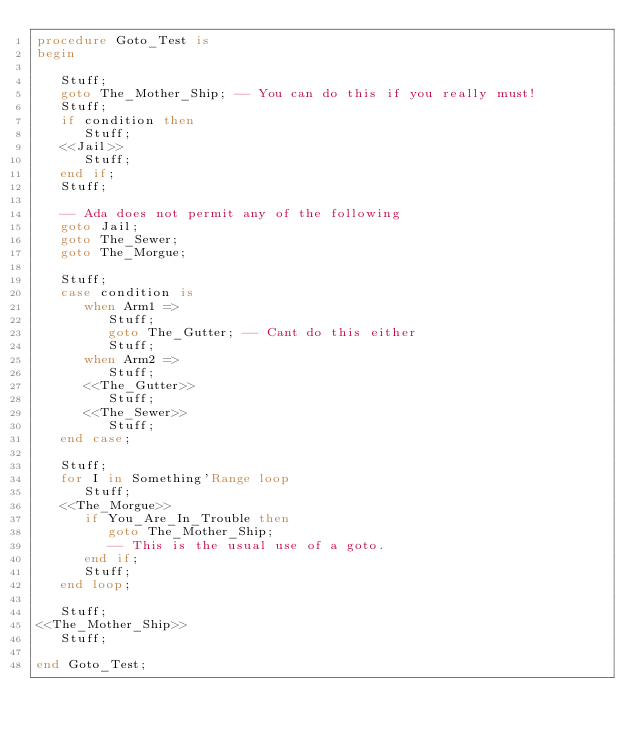<code> <loc_0><loc_0><loc_500><loc_500><_Ada_>procedure Goto_Test is
begin

   Stuff;
   goto The_Mother_Ship; -- You can do this if you really must!
   Stuff;
   if condition then
      Stuff;
   <<Jail>>
      Stuff;
   end if;
   Stuff;

   -- Ada does not permit any of the following
   goto Jail;
   goto The_Sewer;
   goto The_Morgue;

   Stuff;
   case condition is
      when Arm1 =>
         Stuff;
         goto The_Gutter; -- Cant do this either
         Stuff;
      when Arm2 =>
         Stuff;
      <<The_Gutter>>
         Stuff;
      <<The_Sewer>>
         Stuff;
   end case;

   Stuff;
   for I in Something'Range loop
      Stuff;
   <<The_Morgue>>
      if You_Are_In_Trouble then
         goto The_Mother_Ship;
         -- This is the usual use of a goto.
      end if;
      Stuff;
   end loop;

   Stuff;
<<The_Mother_Ship>>
   Stuff;

end Goto_Test;
</code> 